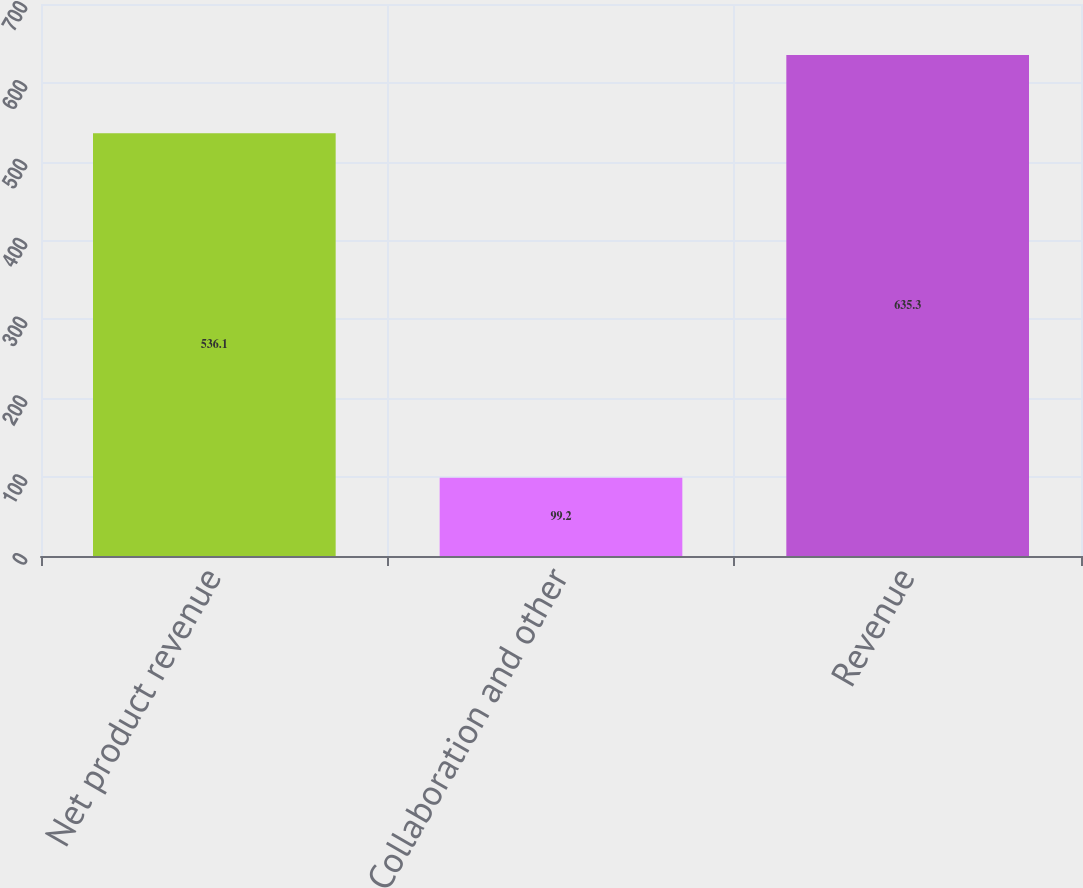<chart> <loc_0><loc_0><loc_500><loc_500><bar_chart><fcel>Net product revenue<fcel>Collaboration and other<fcel>Revenue<nl><fcel>536.1<fcel>99.2<fcel>635.3<nl></chart> 